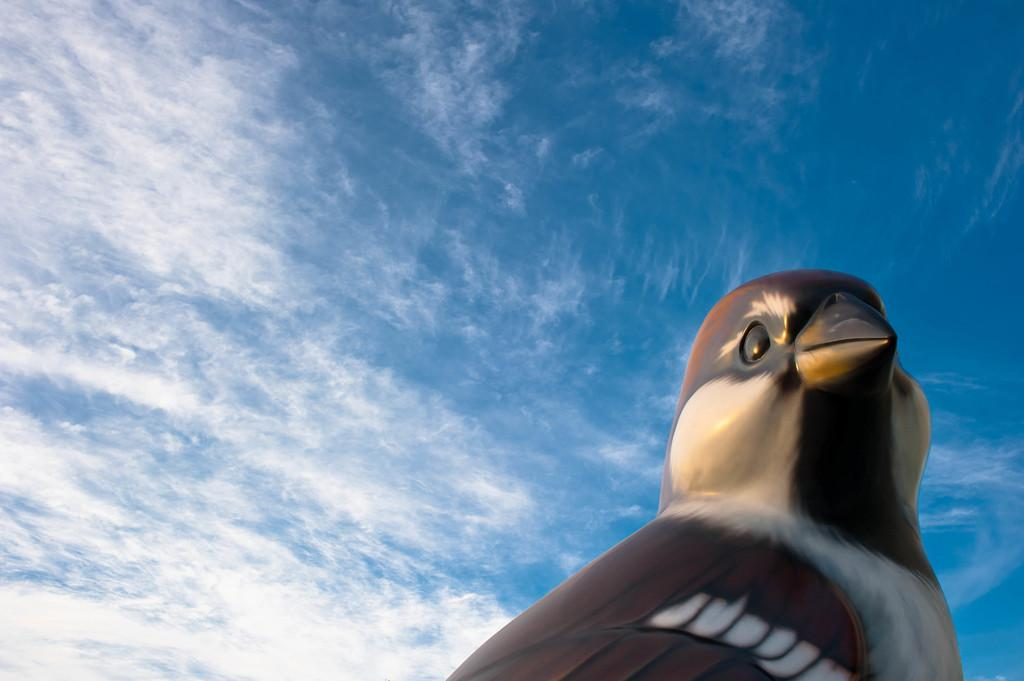What is the main subject of the image? There is a statue of a bird in the image. What can be seen in the background of the image? The sky is visible in the background of the image. How would you describe the sky in the image? The sky appears to be cloudy. How many wheels are attached to the bird statue in the image? There are no wheels attached to the bird statue in the image. What type of egg can be seen in the image? There are no eggs present in the image. 